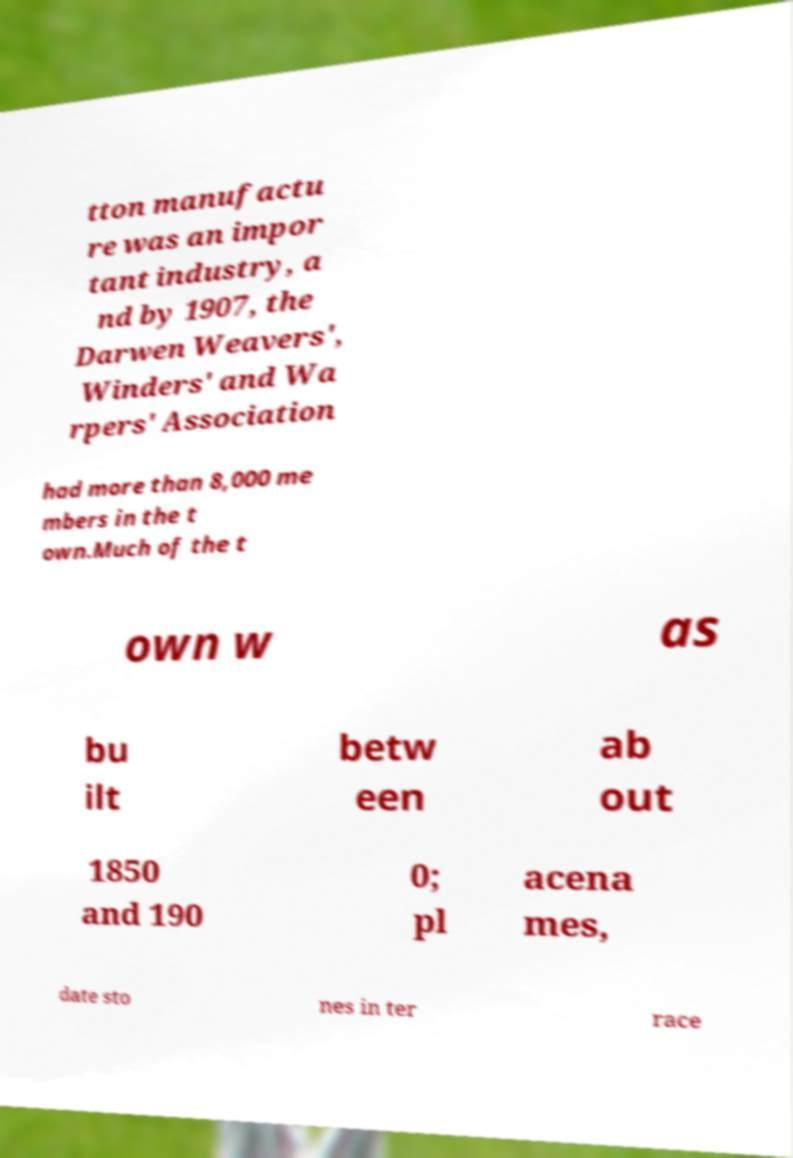Can you accurately transcribe the text from the provided image for me? tton manufactu re was an impor tant industry, a nd by 1907, the Darwen Weavers', Winders' and Wa rpers' Association had more than 8,000 me mbers in the t own.Much of the t own w as bu ilt betw een ab out 1850 and 190 0; pl acena mes, date sto nes in ter race 